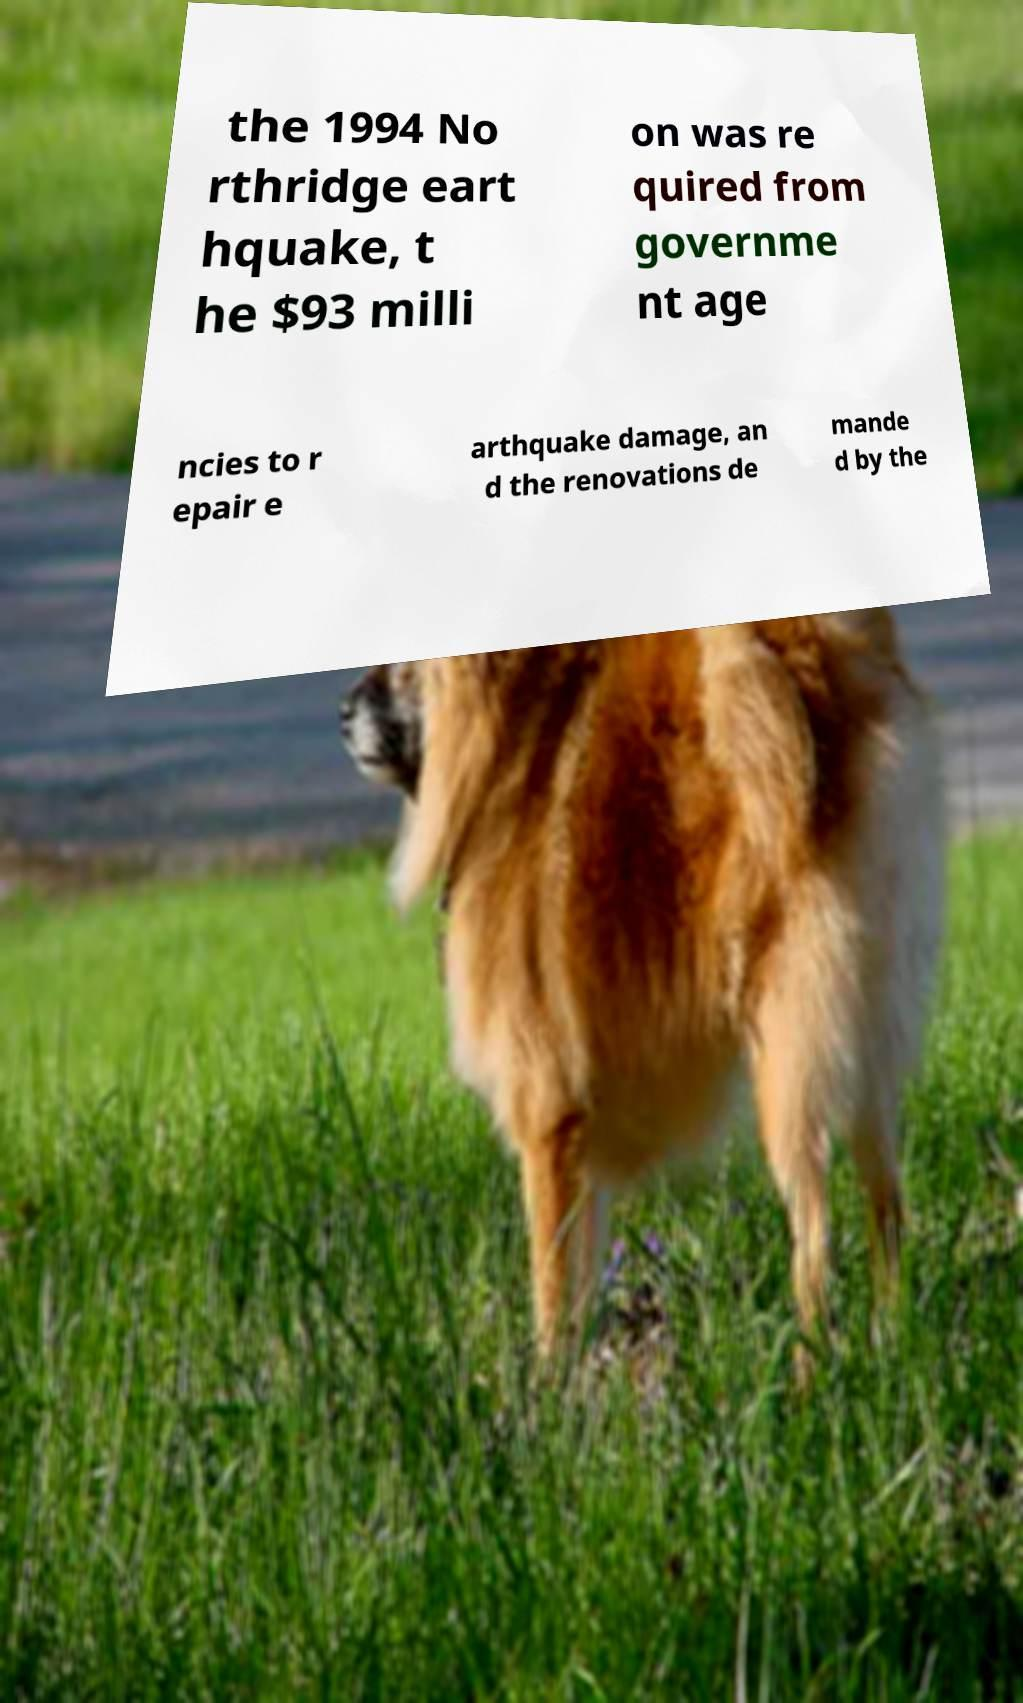Could you assist in decoding the text presented in this image and type it out clearly? the 1994 No rthridge eart hquake, t he $93 milli on was re quired from governme nt age ncies to r epair e arthquake damage, an d the renovations de mande d by the 